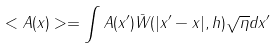Convert formula to latex. <formula><loc_0><loc_0><loc_500><loc_500>< A ( x ) > = \int A ( { x ^ { \prime } } ) \bar { W } ( | { x ^ { \prime } } - { x } | , h ) \sqrt { \eta } d { x ^ { \prime } }</formula> 